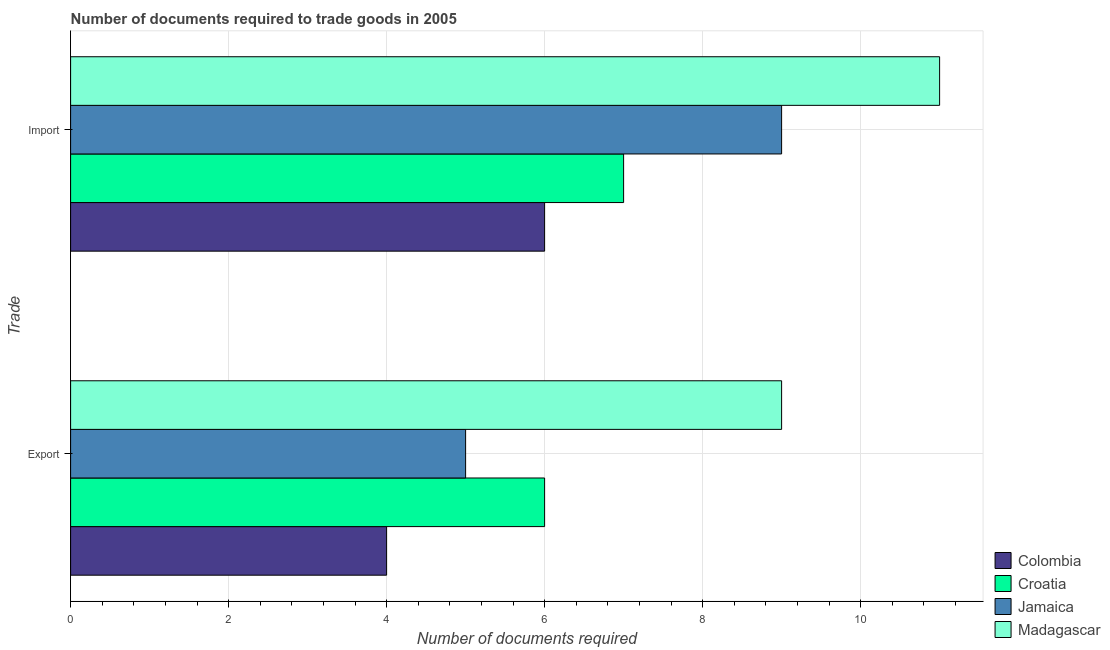How many bars are there on the 1st tick from the top?
Your response must be concise. 4. How many bars are there on the 2nd tick from the bottom?
Provide a short and direct response. 4. What is the label of the 1st group of bars from the top?
Your response must be concise. Import. What is the number of documents required to import goods in Madagascar?
Ensure brevity in your answer.  11. Across all countries, what is the maximum number of documents required to export goods?
Your response must be concise. 9. Across all countries, what is the minimum number of documents required to export goods?
Offer a terse response. 4. In which country was the number of documents required to export goods maximum?
Provide a succinct answer. Madagascar. In which country was the number of documents required to import goods minimum?
Provide a succinct answer. Colombia. What is the total number of documents required to export goods in the graph?
Your answer should be very brief. 24. What is the difference between the number of documents required to export goods in Colombia and that in Madagascar?
Keep it short and to the point. -5. What is the difference between the number of documents required to export goods in Madagascar and the number of documents required to import goods in Jamaica?
Keep it short and to the point. 0. What is the average number of documents required to import goods per country?
Ensure brevity in your answer.  8.25. What is the difference between the number of documents required to import goods and number of documents required to export goods in Jamaica?
Keep it short and to the point. 4. In how many countries, is the number of documents required to import goods greater than 8.4 ?
Offer a very short reply. 2. What is the ratio of the number of documents required to import goods in Colombia to that in Madagascar?
Make the answer very short. 0.55. Is the number of documents required to import goods in Madagascar less than that in Colombia?
Offer a terse response. No. In how many countries, is the number of documents required to import goods greater than the average number of documents required to import goods taken over all countries?
Provide a short and direct response. 2. What does the 2nd bar from the top in Export represents?
Your answer should be compact. Jamaica. What does the 2nd bar from the bottom in Export represents?
Your answer should be compact. Croatia. Are all the bars in the graph horizontal?
Provide a succinct answer. Yes. How many countries are there in the graph?
Offer a very short reply. 4. Does the graph contain any zero values?
Provide a short and direct response. No. Does the graph contain grids?
Give a very brief answer. Yes. Where does the legend appear in the graph?
Make the answer very short. Bottom right. How are the legend labels stacked?
Keep it short and to the point. Vertical. What is the title of the graph?
Make the answer very short. Number of documents required to trade goods in 2005. Does "Tajikistan" appear as one of the legend labels in the graph?
Offer a very short reply. No. What is the label or title of the X-axis?
Offer a very short reply. Number of documents required. What is the label or title of the Y-axis?
Make the answer very short. Trade. What is the Number of documents required of Colombia in Export?
Provide a succinct answer. 4. What is the Number of documents required of Croatia in Export?
Keep it short and to the point. 6. What is the Number of documents required in Jamaica in Export?
Ensure brevity in your answer.  5. What is the Number of documents required in Colombia in Import?
Offer a very short reply. 6. What is the Number of documents required of Croatia in Import?
Your answer should be very brief. 7. What is the Number of documents required in Jamaica in Import?
Your answer should be compact. 9. What is the Number of documents required in Madagascar in Import?
Provide a short and direct response. 11. Across all Trade, what is the maximum Number of documents required in Colombia?
Your answer should be compact. 6. Across all Trade, what is the maximum Number of documents required in Croatia?
Give a very brief answer. 7. Across all Trade, what is the minimum Number of documents required of Colombia?
Your answer should be compact. 4. What is the total Number of documents required of Jamaica in the graph?
Your answer should be very brief. 14. What is the difference between the Number of documents required in Croatia in Export and that in Import?
Give a very brief answer. -1. What is the difference between the Number of documents required of Jamaica in Export and that in Import?
Your answer should be compact. -4. What is the difference between the Number of documents required of Madagascar in Export and that in Import?
Your response must be concise. -2. What is the difference between the Number of documents required of Colombia in Export and the Number of documents required of Croatia in Import?
Keep it short and to the point. -3. What is the difference between the Number of documents required of Colombia in Export and the Number of documents required of Jamaica in Import?
Make the answer very short. -5. What is the difference between the Number of documents required in Colombia in Export and the Number of documents required in Madagascar in Import?
Provide a succinct answer. -7. What is the difference between the Number of documents required in Croatia in Export and the Number of documents required in Jamaica in Import?
Ensure brevity in your answer.  -3. What is the difference between the Number of documents required of Jamaica in Export and the Number of documents required of Madagascar in Import?
Your answer should be very brief. -6. What is the average Number of documents required in Colombia per Trade?
Your answer should be very brief. 5. What is the average Number of documents required in Croatia per Trade?
Give a very brief answer. 6.5. What is the average Number of documents required in Jamaica per Trade?
Your response must be concise. 7. What is the difference between the Number of documents required of Colombia and Number of documents required of Croatia in Export?
Make the answer very short. -2. What is the difference between the Number of documents required of Croatia and Number of documents required of Jamaica in Export?
Give a very brief answer. 1. What is the difference between the Number of documents required in Croatia and Number of documents required in Madagascar in Export?
Keep it short and to the point. -3. What is the difference between the Number of documents required of Jamaica and Number of documents required of Madagascar in Export?
Offer a very short reply. -4. What is the ratio of the Number of documents required of Croatia in Export to that in Import?
Your answer should be compact. 0.86. What is the ratio of the Number of documents required in Jamaica in Export to that in Import?
Your response must be concise. 0.56. What is the ratio of the Number of documents required in Madagascar in Export to that in Import?
Provide a short and direct response. 0.82. What is the difference between the highest and the second highest Number of documents required in Jamaica?
Your answer should be compact. 4. What is the difference between the highest and the lowest Number of documents required of Jamaica?
Keep it short and to the point. 4. What is the difference between the highest and the lowest Number of documents required of Madagascar?
Make the answer very short. 2. 